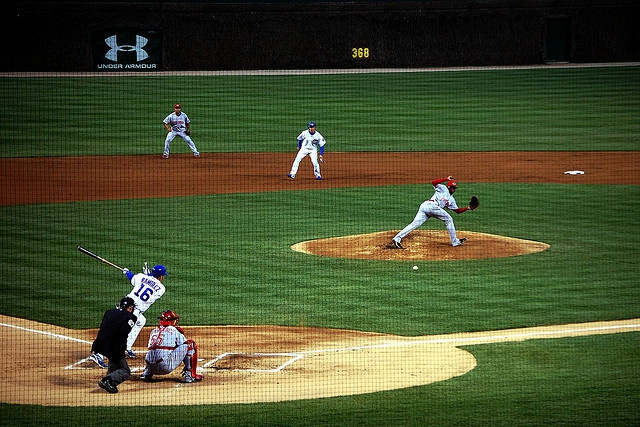Describe the objects in this image and their specific colors. I can see people in black, lightgray, maroon, and darkgray tones, people in black, gray, and white tones, people in black, lightblue, and darkgray tones, people in black, white, navy, and darkgray tones, and people in black, gray, darkgray, and lightblue tones in this image. 